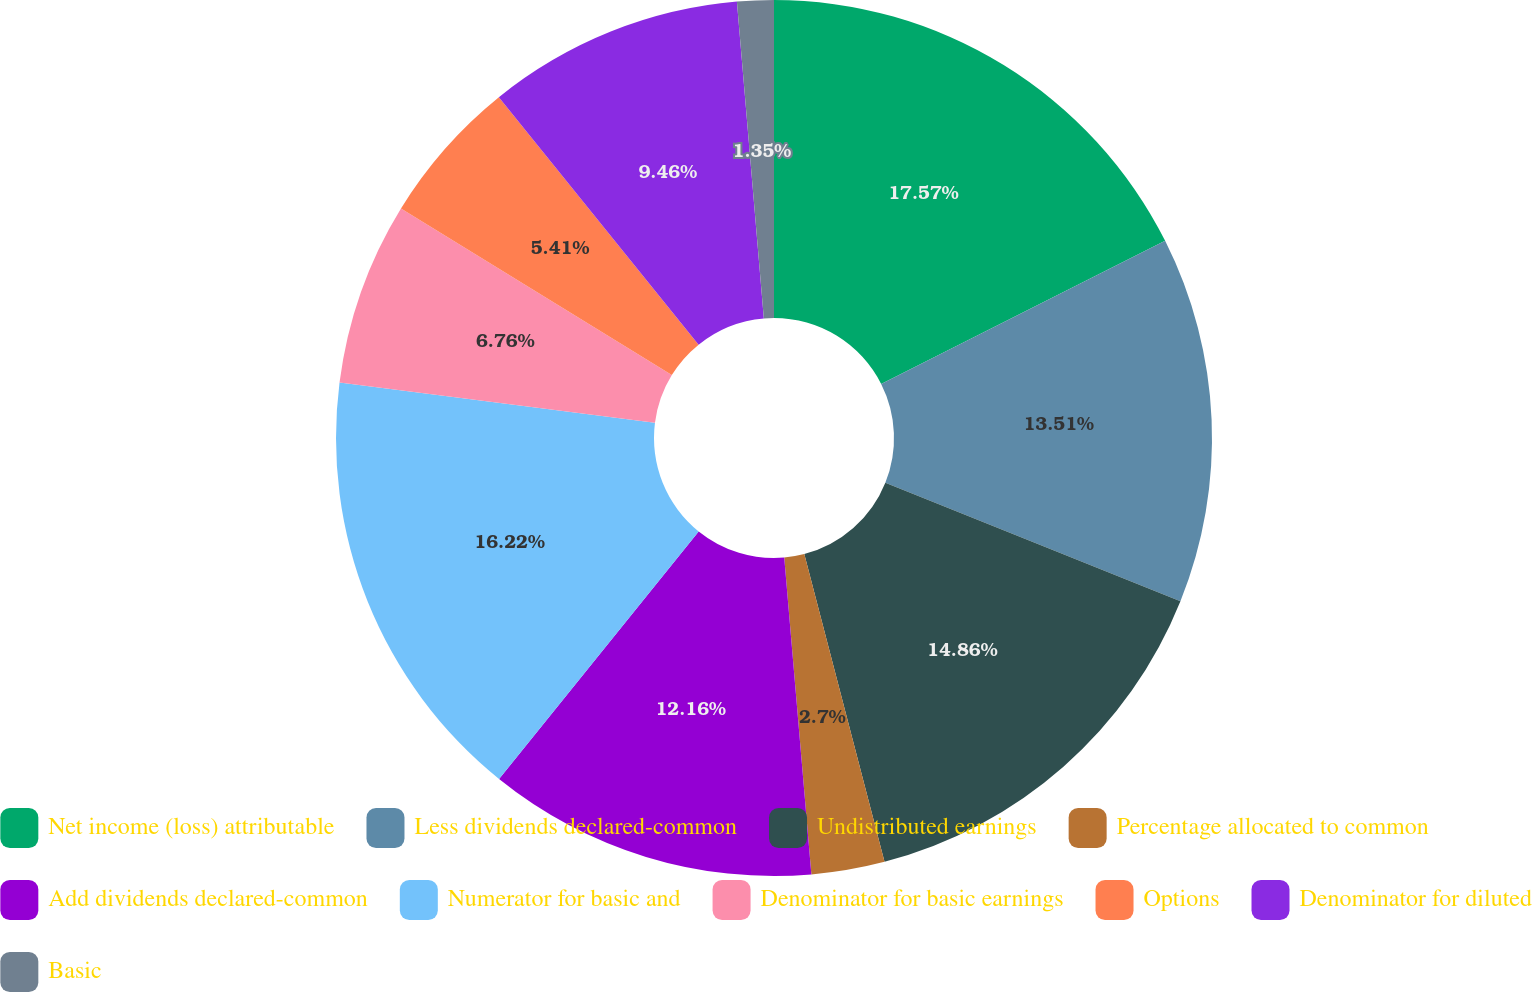<chart> <loc_0><loc_0><loc_500><loc_500><pie_chart><fcel>Net income (loss) attributable<fcel>Less dividends declared-common<fcel>Undistributed earnings<fcel>Percentage allocated to common<fcel>Add dividends declared-common<fcel>Numerator for basic and<fcel>Denominator for basic earnings<fcel>Options<fcel>Denominator for diluted<fcel>Basic<nl><fcel>17.57%<fcel>13.51%<fcel>14.86%<fcel>2.7%<fcel>12.16%<fcel>16.22%<fcel>6.76%<fcel>5.41%<fcel>9.46%<fcel>1.35%<nl></chart> 